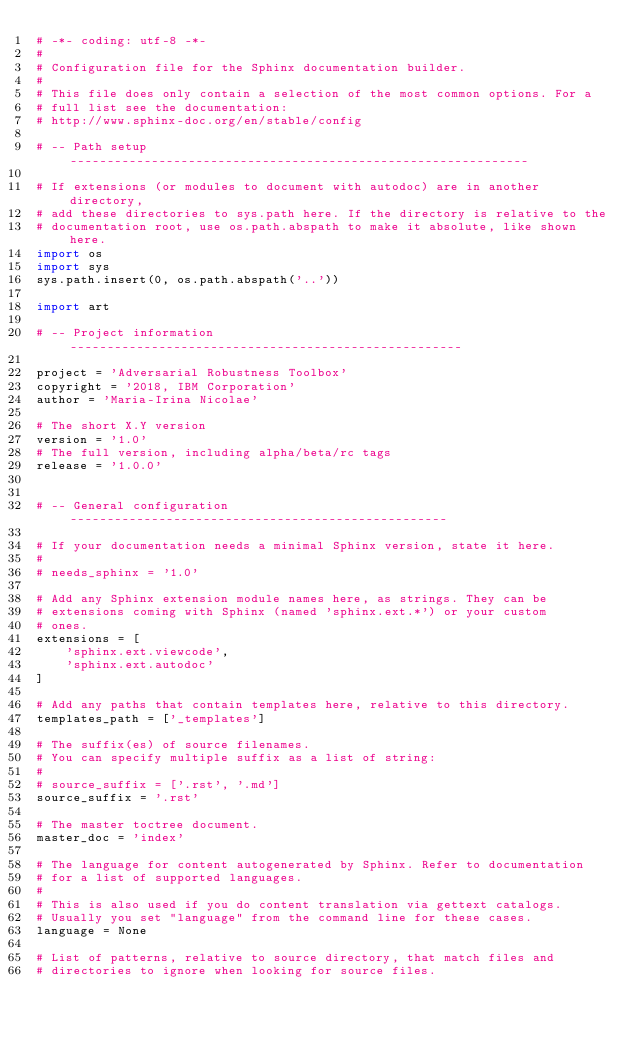Convert code to text. <code><loc_0><loc_0><loc_500><loc_500><_Python_># -*- coding: utf-8 -*-
#
# Configuration file for the Sphinx documentation builder.
#
# This file does only contain a selection of the most common options. For a
# full list see the documentation:
# http://www.sphinx-doc.org/en/stable/config

# -- Path setup --------------------------------------------------------------

# If extensions (or modules to document with autodoc) are in another directory,
# add these directories to sys.path here. If the directory is relative to the
# documentation root, use os.path.abspath to make it absolute, like shown here.
import os
import sys
sys.path.insert(0, os.path.abspath('..'))

import art

# -- Project information -----------------------------------------------------

project = 'Adversarial Robustness Toolbox'
copyright = '2018, IBM Corporation'
author = 'Maria-Irina Nicolae'

# The short X.Y version
version = '1.0'
# The full version, including alpha/beta/rc tags
release = '1.0.0'


# -- General configuration ---------------------------------------------------

# If your documentation needs a minimal Sphinx version, state it here.
#
# needs_sphinx = '1.0'

# Add any Sphinx extension module names here, as strings. They can be
# extensions coming with Sphinx (named 'sphinx.ext.*') or your custom
# ones.
extensions = [
    'sphinx.ext.viewcode',
    'sphinx.ext.autodoc'
]

# Add any paths that contain templates here, relative to this directory.
templates_path = ['_templates']

# The suffix(es) of source filenames.
# You can specify multiple suffix as a list of string:
#
# source_suffix = ['.rst', '.md']
source_suffix = '.rst'

# The master toctree document.
master_doc = 'index'

# The language for content autogenerated by Sphinx. Refer to documentation
# for a list of supported languages.
#
# This is also used if you do content translation via gettext catalogs.
# Usually you set "language" from the command line for these cases.
language = None

# List of patterns, relative to source directory, that match files and
# directories to ignore when looking for source files.</code> 